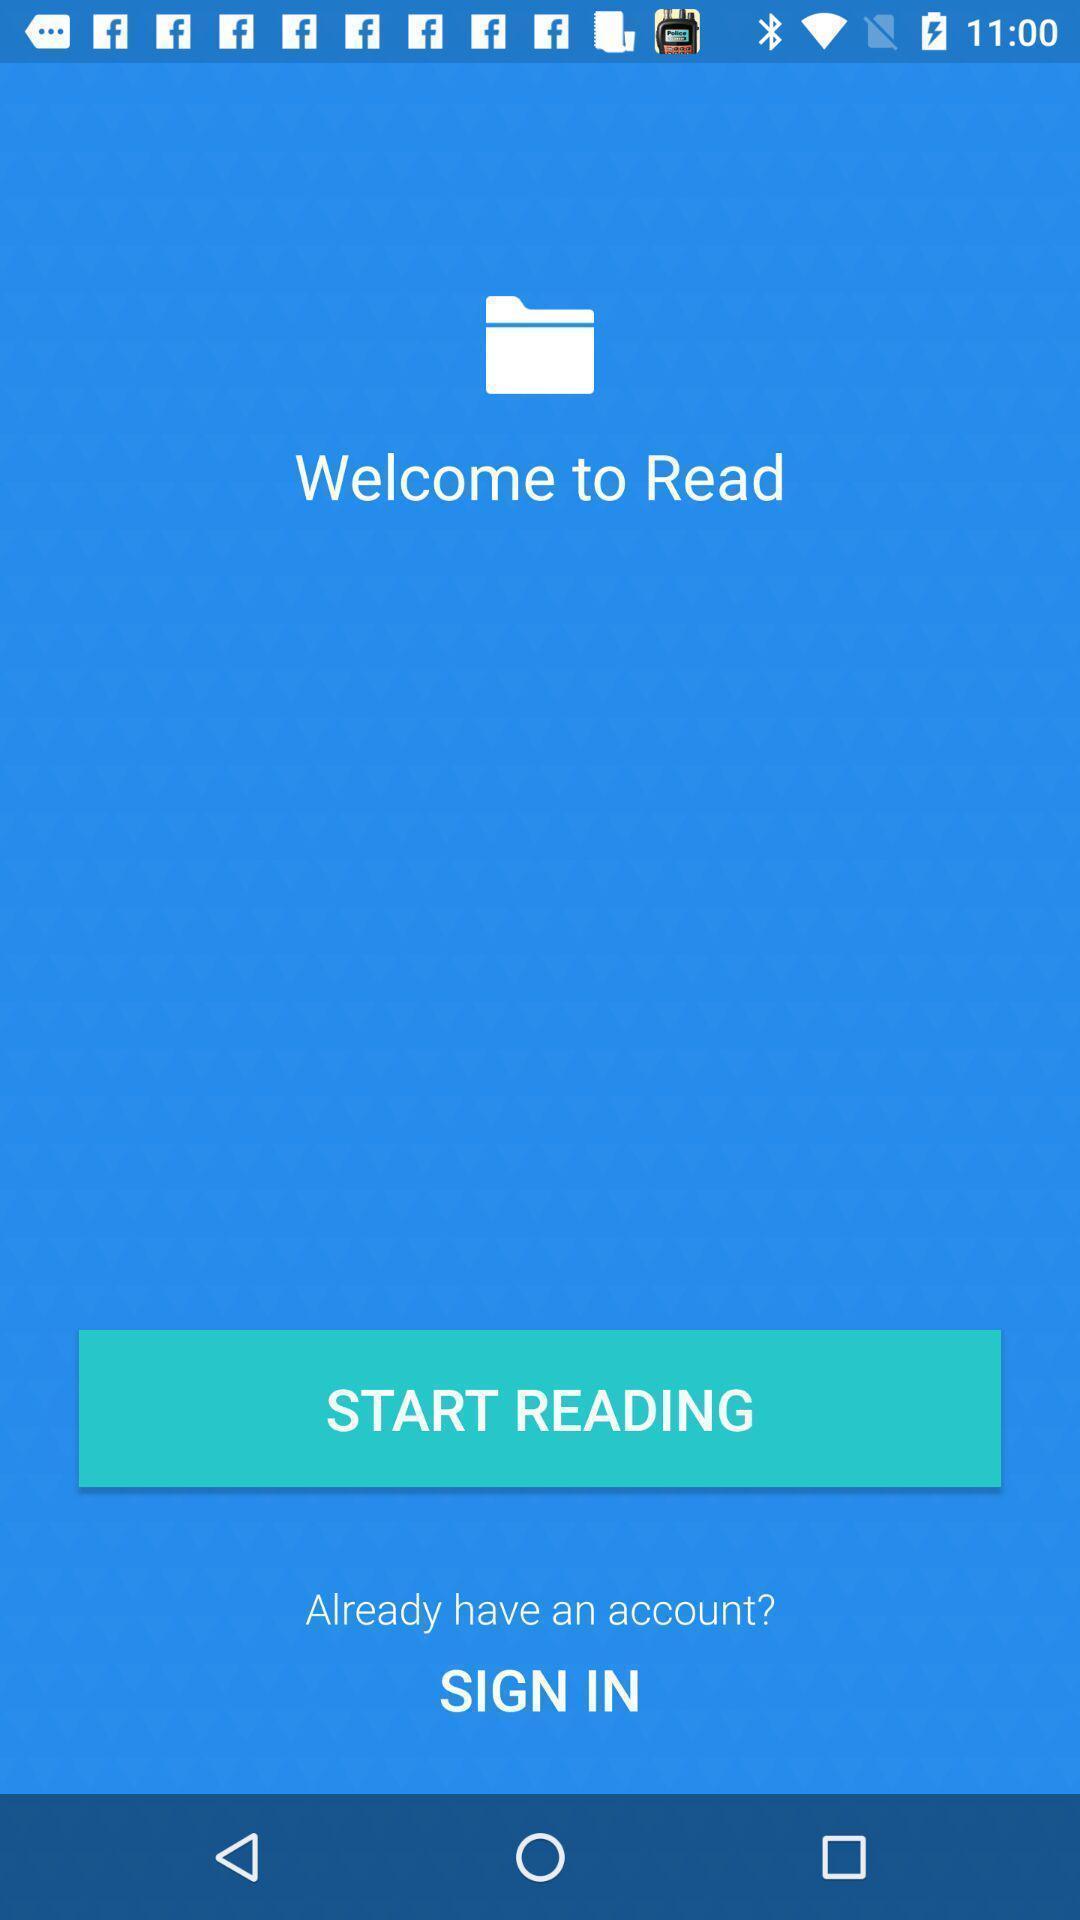Provide a detailed account of this screenshot. Welcome page. 